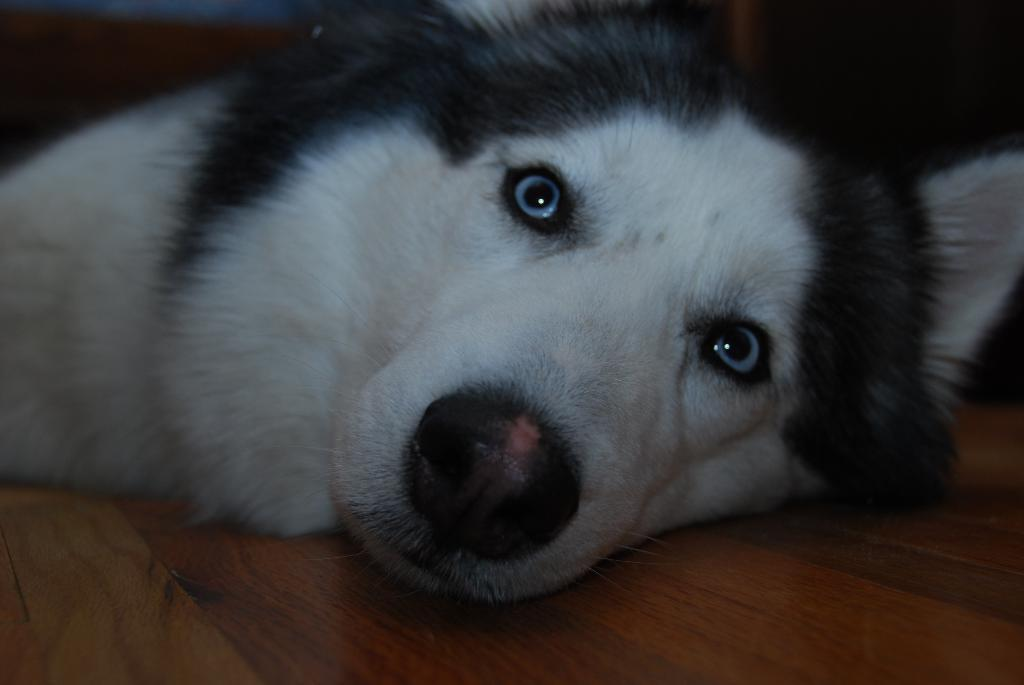What type of animal is present in the image? There is a dog in the image. Can you describe the color pattern of the dog? The dog is white and black in color. What type of feather can be seen on the dog's neck in the image? There is no feather present on the dog's neck in the image. The dog is a canine, and feathers are typically associated with birds, not dogs. 